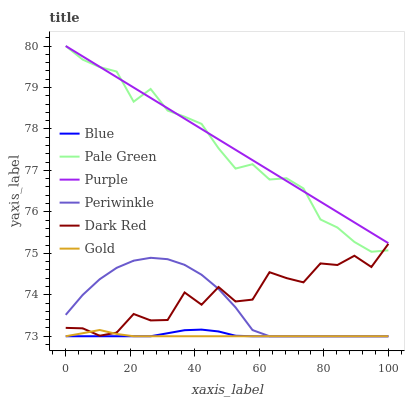Does Gold have the minimum area under the curve?
Answer yes or no. Yes. Does Purple have the maximum area under the curve?
Answer yes or no. Yes. Does Purple have the minimum area under the curve?
Answer yes or no. No. Does Gold have the maximum area under the curve?
Answer yes or no. No. Is Purple the smoothest?
Answer yes or no. Yes. Is Dark Red the roughest?
Answer yes or no. Yes. Is Gold the smoothest?
Answer yes or no. No. Is Gold the roughest?
Answer yes or no. No. Does Purple have the lowest value?
Answer yes or no. No. Does Pale Green have the highest value?
Answer yes or no. Yes. Does Gold have the highest value?
Answer yes or no. No. Is Gold less than Purple?
Answer yes or no. Yes. Is Purple greater than Blue?
Answer yes or no. Yes. Does Blue intersect Gold?
Answer yes or no. Yes. Is Blue less than Gold?
Answer yes or no. No. Is Blue greater than Gold?
Answer yes or no. No. Does Gold intersect Purple?
Answer yes or no. No. 